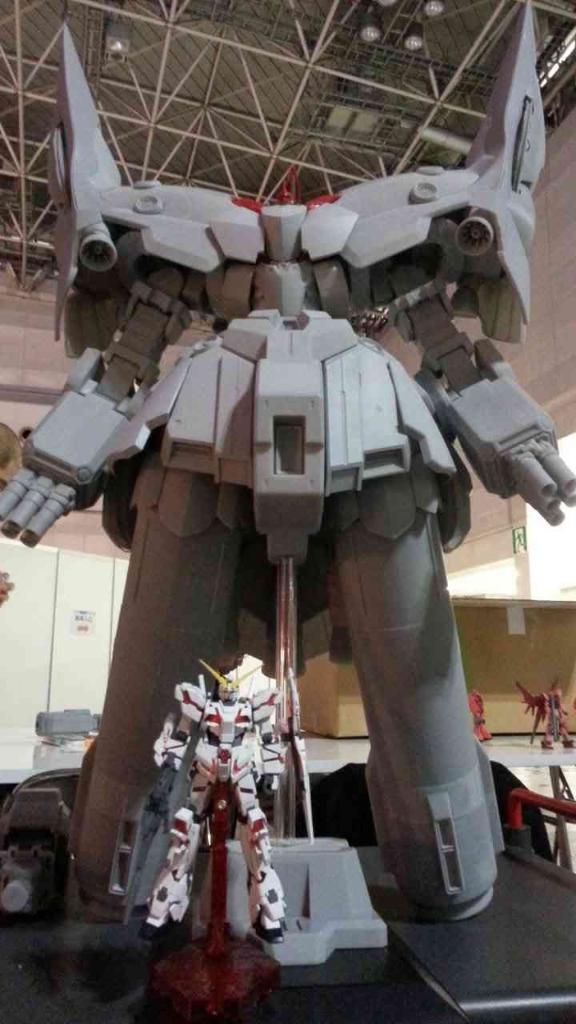What type of toys are featured in the image? There are transformer robots of different sizes in the image. Where is the image likely taken? The image appears to be on a table. What is the purpose of the board in the image? The purpose of the board is not specified, but it could be used for displaying or organizing the robots. What can be seen on the roof in the image? The roof has lights and iron poles visible. How does the transformer robot slip on the table in the image? There is no indication that the transformer robots are slipping on the table in the image. 